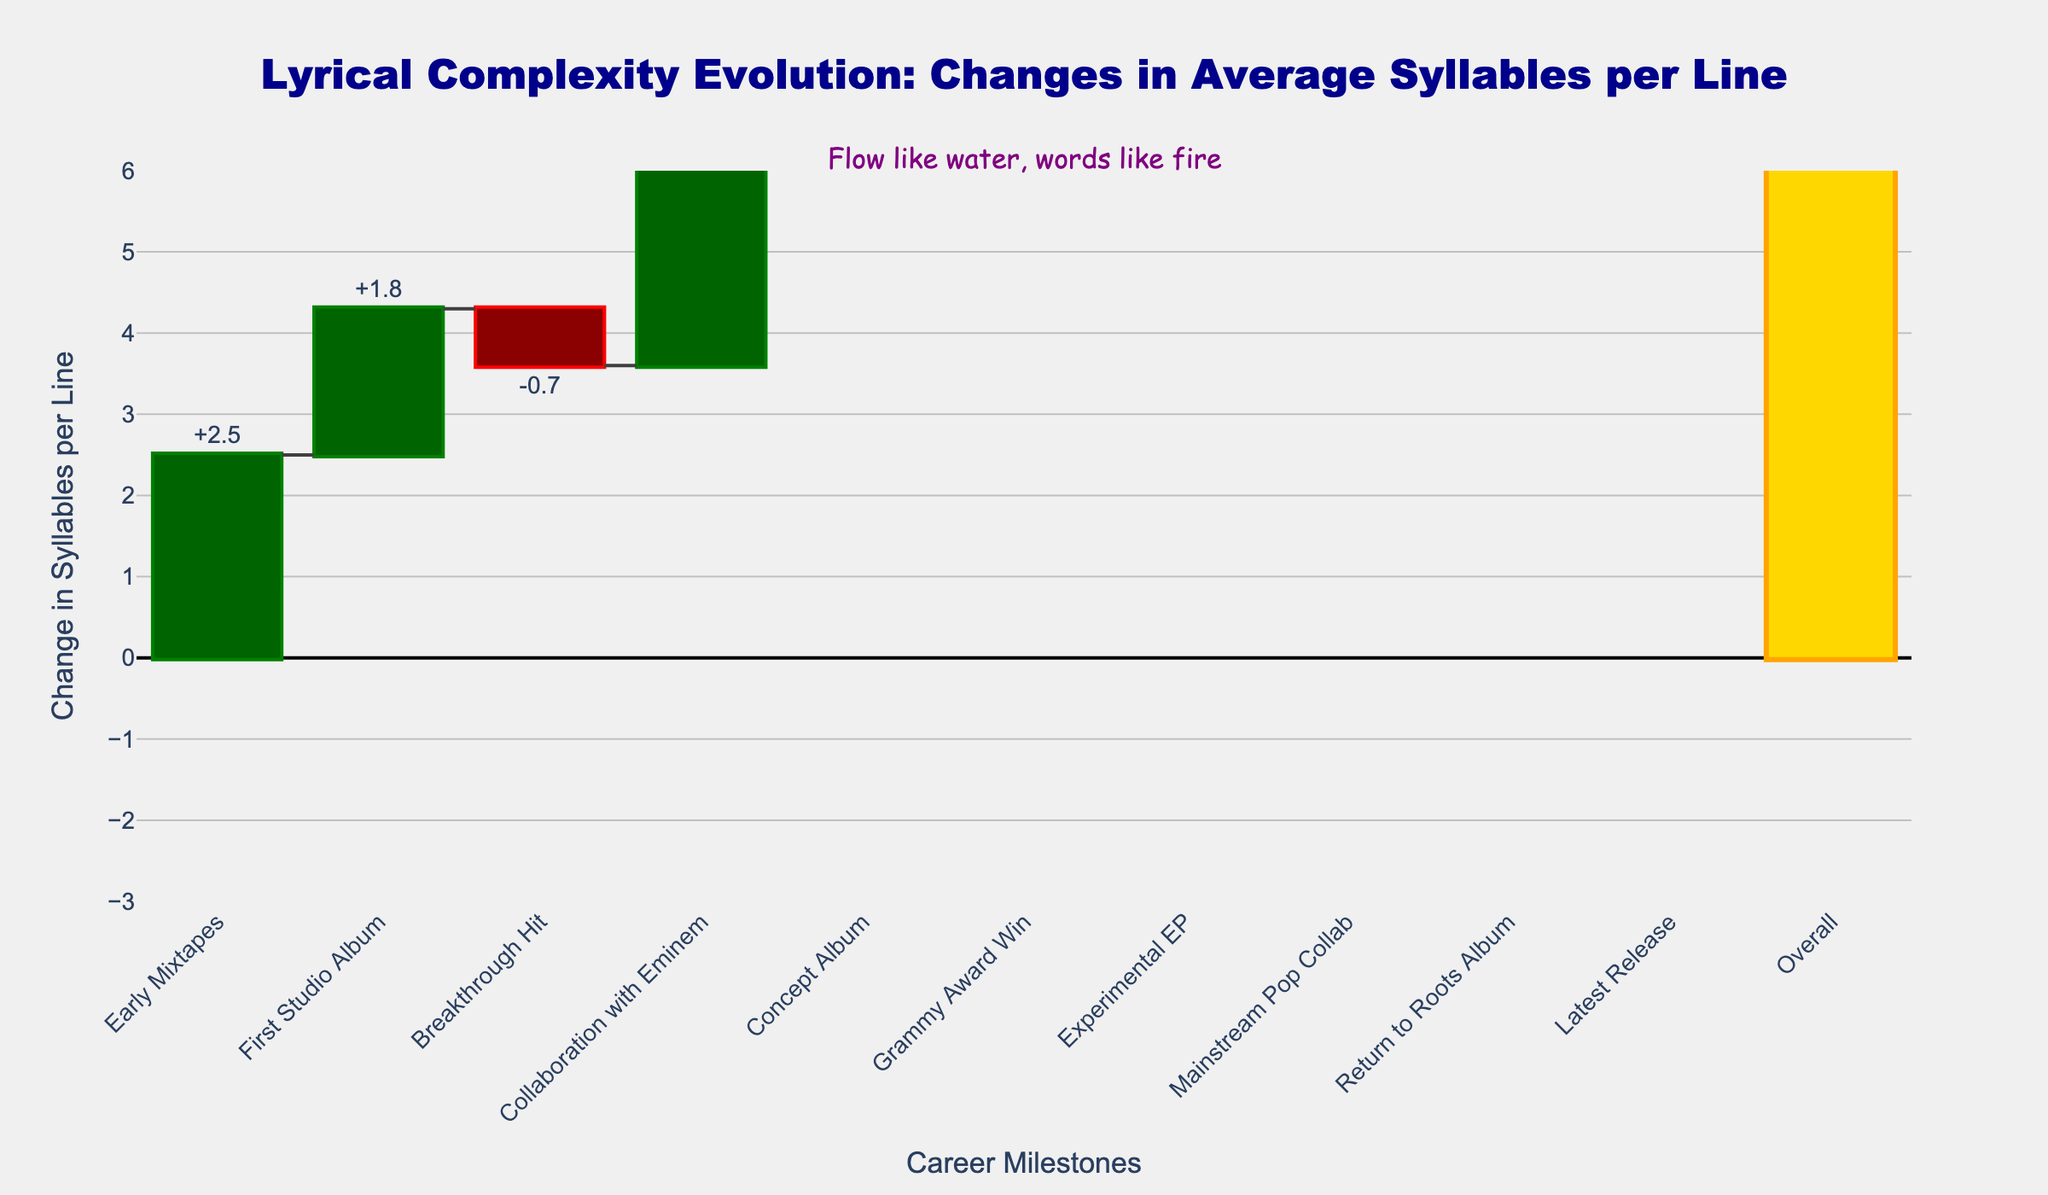what is the total change in syllables per line across all career milestones? To find the total change, you need to sum up all the changes listed in the figure. This includes positive and negative changes across all career milestones.
Answer: +12.5 what is the title of the chart? The title of the chart is clearly displayed at the top of the figure.
Answer: Lyrical Complexity Evolution: Changes in Average Syllables per Line Which career milestone has the highest increase in average syllables per line? The highest increase can be identified by finding the bar with the maximum upward length.
Answer: Experimental EP how many career milestones resulted in a decrease in average syllables per line? To determine this, count the number of bars that extend below the x-axis.
Answer: 3 What was the change in syllables per line after the collaboration with Eminem and before the Grammy Award win? This requires identifying the changes associated with these milestones from the figure and noting their order.
Answer: +3.2 and -1.4 how much did the average syllables per line change after the concept album compared to the first studio album? Subtract the change at the first studio album from the change at the concept album
Answer: 2.1 - 1.8 = 0.3 What color are the bars representing milestones that resulted in an increase? Identify the combination of color and direction for increasing bars.
Answer: Dark Green What's the combined change in average syllables per line for the early mixtapes and breakthrough hit? Add the changes listed for early mixtapes and breakthrough hit.
Answer: 2 + (-0.7) = 1.3 What's the overall change by the time of the latest release compared to the early mixtapes? Sum the changes from early mixtapes through the latest release.
Answer: +12.5 In terms of syllabic complexity, by how much did "Experimental EP" change compared to the "Mainstream Pop Collab"? Identify the changes for each milestone and calculate the difference.
Answer: 4.6 - (-2.3) = 6.9 